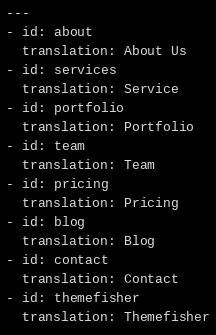Convert code to text. <code><loc_0><loc_0><loc_500><loc_500><_YAML_>---
- id: about
  translation: About Us
- id: services
  translation: Service
- id: portfolio
  translation: Portfolio
- id: team
  translation: Team
- id: pricing
  translation: Pricing
- id: blog
  translation: Blog
- id: contact
  translation: Contact
- id: themefisher
  translation: Themefisher
</code> 